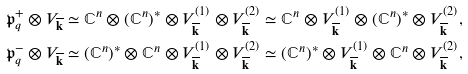Convert formula to latex. <formula><loc_0><loc_0><loc_500><loc_500>& \mathfrak { p } _ { q } ^ { + } \otimes V _ { \overline { \mathbf k } } \simeq \mathbb { C } ^ { n } \otimes ( \mathbb { C } ^ { n } ) ^ { * } \otimes V _ { \overline { \mathbf k } } ^ { ( 1 ) } \otimes V _ { \overline { \mathbf k } } ^ { ( 2 ) } \simeq \mathbb { C } ^ { n } \otimes V _ { \overline { \mathbf k } } ^ { ( 1 ) } \otimes ( \mathbb { C } ^ { n } ) ^ { * } \otimes V _ { \overline { \mathbf k } } ^ { ( 2 ) } , \\ & \mathfrak { p } _ { q } ^ { - } \otimes V _ { \overline { \mathbf k } } \simeq ( \mathbb { C } ^ { n } ) ^ { * } \otimes \mathbb { C } ^ { n } \otimes V _ { \overline { \mathbf k } } ^ { ( 1 ) } \otimes V _ { \overline { \mathbf k } } ^ { ( 2 ) } \simeq ( \mathbb { C } ^ { n } ) ^ { * } \otimes V _ { \overline { \mathbf k } } ^ { ( 1 ) } \otimes \mathbb { C } ^ { n } \otimes V _ { \overline { \mathbf k } } ^ { ( 2 ) } ,</formula> 